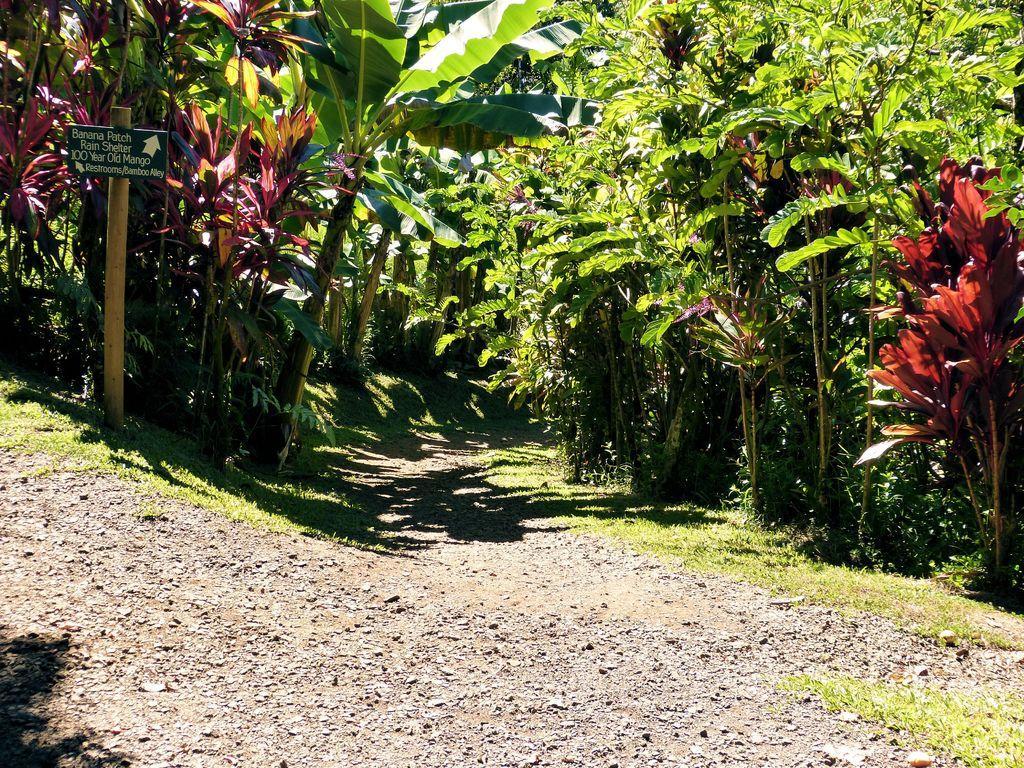Describe this image in one or two sentences. In this image I can see on the left side there is a board in the middle there are trees, at the bottom it is the soil. 